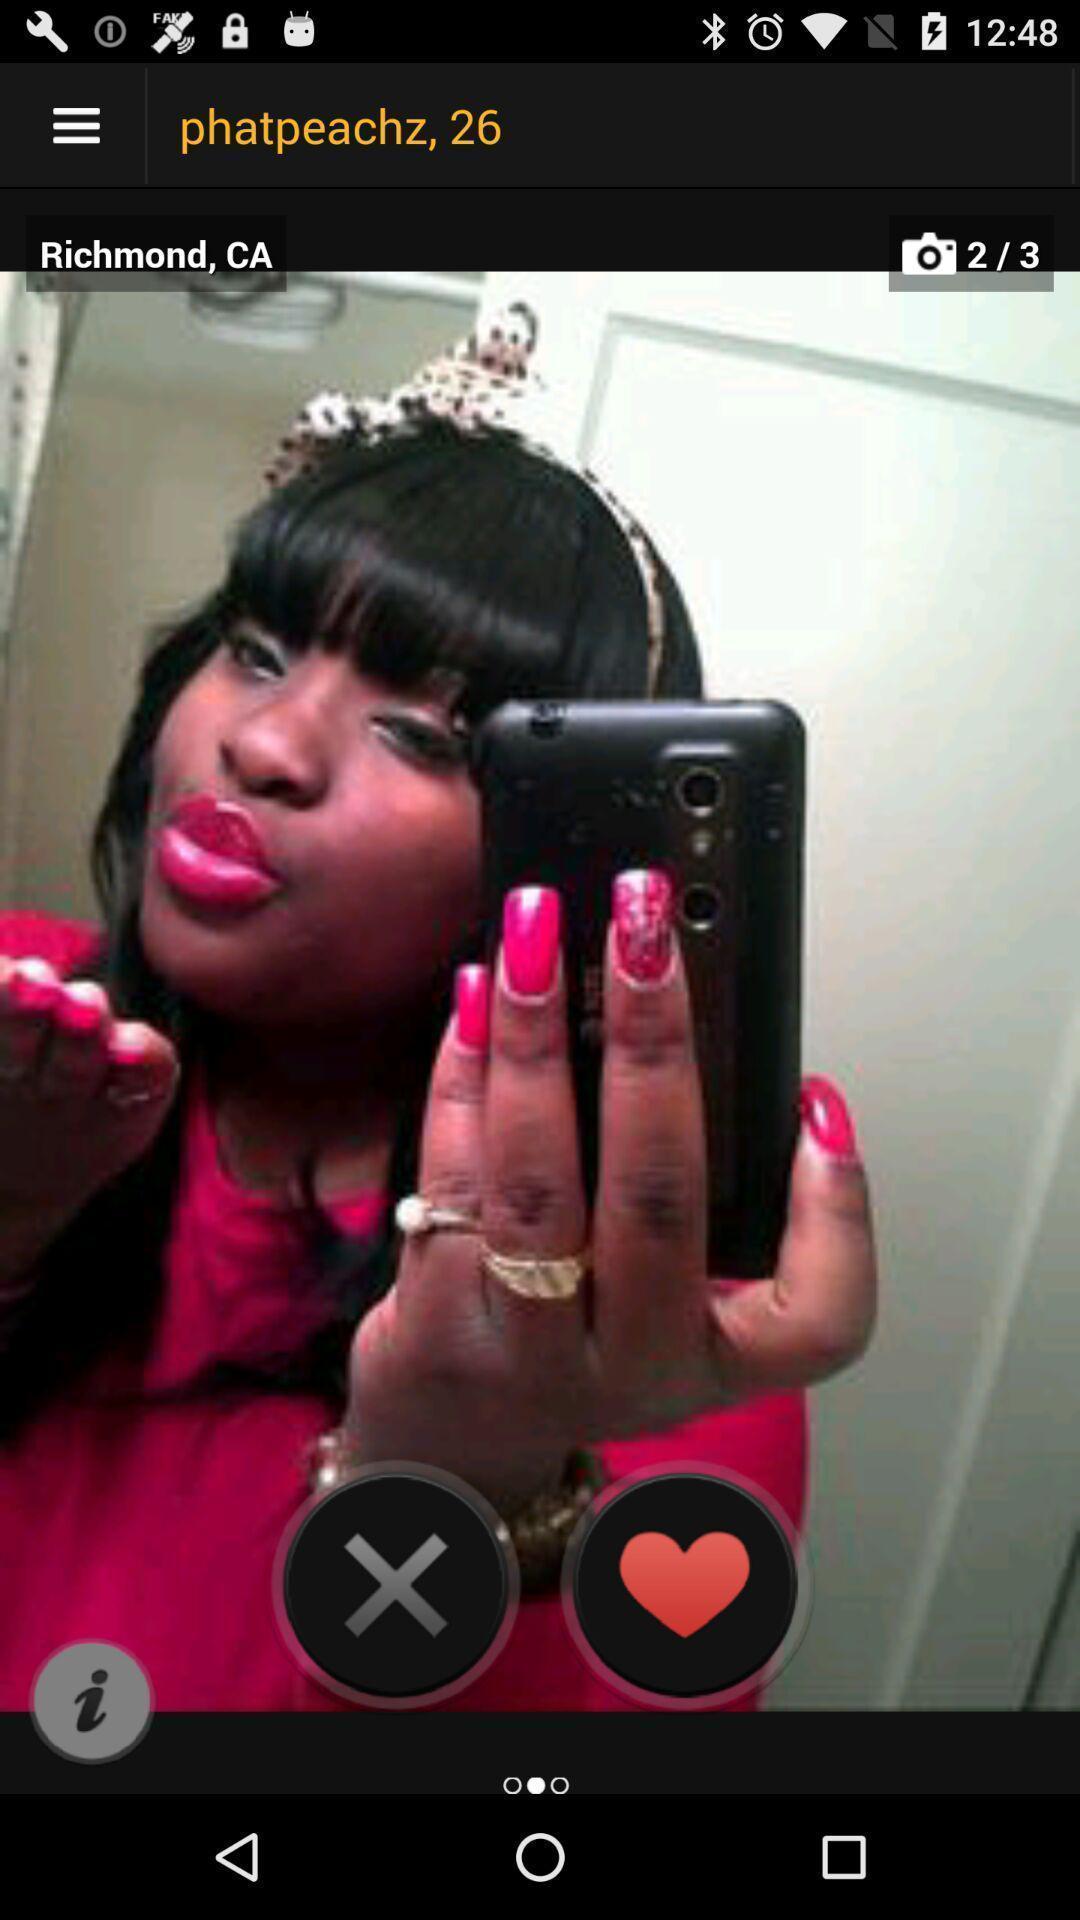Explain what's happening in this screen capture. Page shows an image in the photo app. 